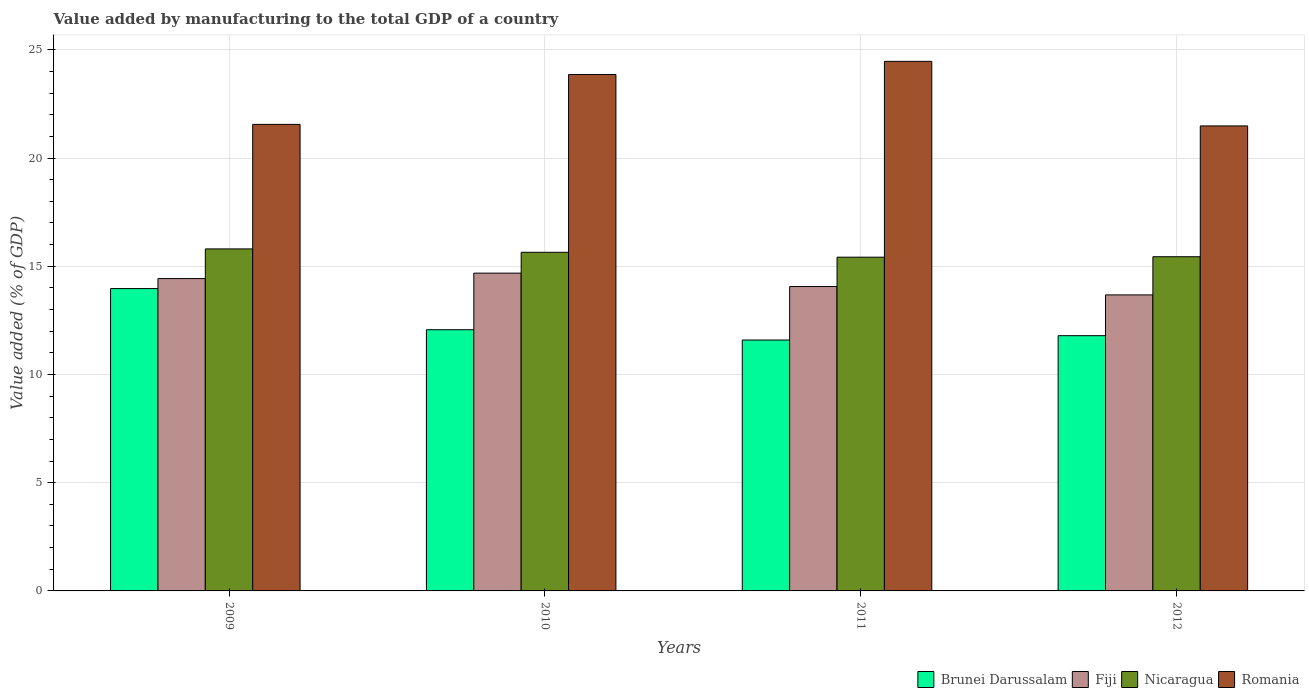How many groups of bars are there?
Provide a short and direct response. 4. Are the number of bars on each tick of the X-axis equal?
Offer a very short reply. Yes. How many bars are there on the 2nd tick from the right?
Provide a succinct answer. 4. What is the value added by manufacturing to the total GDP in Romania in 2012?
Give a very brief answer. 21.48. Across all years, what is the maximum value added by manufacturing to the total GDP in Brunei Darussalam?
Provide a succinct answer. 13.97. Across all years, what is the minimum value added by manufacturing to the total GDP in Brunei Darussalam?
Make the answer very short. 11.59. In which year was the value added by manufacturing to the total GDP in Romania maximum?
Your answer should be compact. 2011. What is the total value added by manufacturing to the total GDP in Nicaragua in the graph?
Offer a very short reply. 62.31. What is the difference between the value added by manufacturing to the total GDP in Fiji in 2009 and that in 2010?
Keep it short and to the point. -0.25. What is the difference between the value added by manufacturing to the total GDP in Fiji in 2011 and the value added by manufacturing to the total GDP in Brunei Darussalam in 2010?
Make the answer very short. 2. What is the average value added by manufacturing to the total GDP in Nicaragua per year?
Give a very brief answer. 15.58. In the year 2009, what is the difference between the value added by manufacturing to the total GDP in Nicaragua and value added by manufacturing to the total GDP in Fiji?
Provide a short and direct response. 1.37. What is the ratio of the value added by manufacturing to the total GDP in Nicaragua in 2009 to that in 2012?
Your response must be concise. 1.02. Is the value added by manufacturing to the total GDP in Romania in 2009 less than that in 2011?
Offer a very short reply. Yes. Is the difference between the value added by manufacturing to the total GDP in Nicaragua in 2009 and 2010 greater than the difference between the value added by manufacturing to the total GDP in Fiji in 2009 and 2010?
Provide a succinct answer. Yes. What is the difference between the highest and the second highest value added by manufacturing to the total GDP in Brunei Darussalam?
Provide a succinct answer. 1.9. What is the difference between the highest and the lowest value added by manufacturing to the total GDP in Brunei Darussalam?
Offer a very short reply. 2.38. Is the sum of the value added by manufacturing to the total GDP in Nicaragua in 2009 and 2010 greater than the maximum value added by manufacturing to the total GDP in Romania across all years?
Keep it short and to the point. Yes. Is it the case that in every year, the sum of the value added by manufacturing to the total GDP in Brunei Darussalam and value added by manufacturing to the total GDP in Fiji is greater than the sum of value added by manufacturing to the total GDP in Nicaragua and value added by manufacturing to the total GDP in Romania?
Offer a very short reply. No. What does the 3rd bar from the left in 2010 represents?
Give a very brief answer. Nicaragua. What does the 4th bar from the right in 2012 represents?
Your answer should be compact. Brunei Darussalam. How many bars are there?
Provide a short and direct response. 16. Are all the bars in the graph horizontal?
Keep it short and to the point. No. How many years are there in the graph?
Make the answer very short. 4. What is the difference between two consecutive major ticks on the Y-axis?
Provide a succinct answer. 5. How many legend labels are there?
Your response must be concise. 4. What is the title of the graph?
Provide a succinct answer. Value added by manufacturing to the total GDP of a country. What is the label or title of the X-axis?
Give a very brief answer. Years. What is the label or title of the Y-axis?
Provide a succinct answer. Value added (% of GDP). What is the Value added (% of GDP) of Brunei Darussalam in 2009?
Make the answer very short. 13.97. What is the Value added (% of GDP) in Fiji in 2009?
Your answer should be very brief. 14.43. What is the Value added (% of GDP) of Nicaragua in 2009?
Offer a terse response. 15.8. What is the Value added (% of GDP) of Romania in 2009?
Offer a terse response. 21.56. What is the Value added (% of GDP) of Brunei Darussalam in 2010?
Make the answer very short. 12.07. What is the Value added (% of GDP) in Fiji in 2010?
Ensure brevity in your answer.  14.68. What is the Value added (% of GDP) in Nicaragua in 2010?
Keep it short and to the point. 15.65. What is the Value added (% of GDP) in Romania in 2010?
Provide a short and direct response. 23.86. What is the Value added (% of GDP) of Brunei Darussalam in 2011?
Give a very brief answer. 11.59. What is the Value added (% of GDP) in Fiji in 2011?
Keep it short and to the point. 14.06. What is the Value added (% of GDP) of Nicaragua in 2011?
Offer a terse response. 15.42. What is the Value added (% of GDP) of Romania in 2011?
Keep it short and to the point. 24.47. What is the Value added (% of GDP) of Brunei Darussalam in 2012?
Ensure brevity in your answer.  11.79. What is the Value added (% of GDP) in Fiji in 2012?
Make the answer very short. 13.68. What is the Value added (% of GDP) of Nicaragua in 2012?
Keep it short and to the point. 15.44. What is the Value added (% of GDP) in Romania in 2012?
Offer a very short reply. 21.48. Across all years, what is the maximum Value added (% of GDP) of Brunei Darussalam?
Offer a terse response. 13.97. Across all years, what is the maximum Value added (% of GDP) of Fiji?
Offer a very short reply. 14.68. Across all years, what is the maximum Value added (% of GDP) in Nicaragua?
Keep it short and to the point. 15.8. Across all years, what is the maximum Value added (% of GDP) in Romania?
Provide a succinct answer. 24.47. Across all years, what is the minimum Value added (% of GDP) of Brunei Darussalam?
Give a very brief answer. 11.59. Across all years, what is the minimum Value added (% of GDP) of Fiji?
Your answer should be very brief. 13.68. Across all years, what is the minimum Value added (% of GDP) of Nicaragua?
Your response must be concise. 15.42. Across all years, what is the minimum Value added (% of GDP) in Romania?
Your response must be concise. 21.48. What is the total Value added (% of GDP) of Brunei Darussalam in the graph?
Your response must be concise. 49.42. What is the total Value added (% of GDP) in Fiji in the graph?
Offer a very short reply. 56.85. What is the total Value added (% of GDP) of Nicaragua in the graph?
Offer a very short reply. 62.31. What is the total Value added (% of GDP) in Romania in the graph?
Provide a short and direct response. 91.37. What is the difference between the Value added (% of GDP) of Brunei Darussalam in 2009 and that in 2010?
Give a very brief answer. 1.9. What is the difference between the Value added (% of GDP) in Fiji in 2009 and that in 2010?
Your response must be concise. -0.25. What is the difference between the Value added (% of GDP) of Nicaragua in 2009 and that in 2010?
Offer a terse response. 0.16. What is the difference between the Value added (% of GDP) in Romania in 2009 and that in 2010?
Provide a succinct answer. -2.3. What is the difference between the Value added (% of GDP) of Brunei Darussalam in 2009 and that in 2011?
Provide a succinct answer. 2.38. What is the difference between the Value added (% of GDP) in Fiji in 2009 and that in 2011?
Make the answer very short. 0.37. What is the difference between the Value added (% of GDP) in Nicaragua in 2009 and that in 2011?
Ensure brevity in your answer.  0.38. What is the difference between the Value added (% of GDP) of Romania in 2009 and that in 2011?
Provide a short and direct response. -2.91. What is the difference between the Value added (% of GDP) in Brunei Darussalam in 2009 and that in 2012?
Provide a succinct answer. 2.18. What is the difference between the Value added (% of GDP) of Fiji in 2009 and that in 2012?
Give a very brief answer. 0.75. What is the difference between the Value added (% of GDP) of Nicaragua in 2009 and that in 2012?
Offer a terse response. 0.36. What is the difference between the Value added (% of GDP) of Romania in 2009 and that in 2012?
Make the answer very short. 0.07. What is the difference between the Value added (% of GDP) in Brunei Darussalam in 2010 and that in 2011?
Provide a short and direct response. 0.48. What is the difference between the Value added (% of GDP) in Fiji in 2010 and that in 2011?
Provide a succinct answer. 0.62. What is the difference between the Value added (% of GDP) of Nicaragua in 2010 and that in 2011?
Offer a very short reply. 0.23. What is the difference between the Value added (% of GDP) in Romania in 2010 and that in 2011?
Give a very brief answer. -0.61. What is the difference between the Value added (% of GDP) in Brunei Darussalam in 2010 and that in 2012?
Your answer should be very brief. 0.27. What is the difference between the Value added (% of GDP) in Fiji in 2010 and that in 2012?
Your response must be concise. 1.01. What is the difference between the Value added (% of GDP) of Nicaragua in 2010 and that in 2012?
Your answer should be compact. 0.21. What is the difference between the Value added (% of GDP) of Romania in 2010 and that in 2012?
Make the answer very short. 2.38. What is the difference between the Value added (% of GDP) of Brunei Darussalam in 2011 and that in 2012?
Your answer should be compact. -0.2. What is the difference between the Value added (% of GDP) in Fiji in 2011 and that in 2012?
Your answer should be very brief. 0.39. What is the difference between the Value added (% of GDP) in Nicaragua in 2011 and that in 2012?
Offer a terse response. -0.02. What is the difference between the Value added (% of GDP) of Romania in 2011 and that in 2012?
Your answer should be very brief. 2.98. What is the difference between the Value added (% of GDP) in Brunei Darussalam in 2009 and the Value added (% of GDP) in Fiji in 2010?
Provide a short and direct response. -0.71. What is the difference between the Value added (% of GDP) of Brunei Darussalam in 2009 and the Value added (% of GDP) of Nicaragua in 2010?
Make the answer very short. -1.68. What is the difference between the Value added (% of GDP) of Brunei Darussalam in 2009 and the Value added (% of GDP) of Romania in 2010?
Your answer should be very brief. -9.89. What is the difference between the Value added (% of GDP) in Fiji in 2009 and the Value added (% of GDP) in Nicaragua in 2010?
Make the answer very short. -1.21. What is the difference between the Value added (% of GDP) in Fiji in 2009 and the Value added (% of GDP) in Romania in 2010?
Give a very brief answer. -9.43. What is the difference between the Value added (% of GDP) in Nicaragua in 2009 and the Value added (% of GDP) in Romania in 2010?
Ensure brevity in your answer.  -8.06. What is the difference between the Value added (% of GDP) in Brunei Darussalam in 2009 and the Value added (% of GDP) in Fiji in 2011?
Your response must be concise. -0.09. What is the difference between the Value added (% of GDP) in Brunei Darussalam in 2009 and the Value added (% of GDP) in Nicaragua in 2011?
Ensure brevity in your answer.  -1.45. What is the difference between the Value added (% of GDP) in Brunei Darussalam in 2009 and the Value added (% of GDP) in Romania in 2011?
Ensure brevity in your answer.  -10.5. What is the difference between the Value added (% of GDP) of Fiji in 2009 and the Value added (% of GDP) of Nicaragua in 2011?
Offer a terse response. -0.99. What is the difference between the Value added (% of GDP) of Fiji in 2009 and the Value added (% of GDP) of Romania in 2011?
Offer a very short reply. -10.04. What is the difference between the Value added (% of GDP) in Nicaragua in 2009 and the Value added (% of GDP) in Romania in 2011?
Make the answer very short. -8.67. What is the difference between the Value added (% of GDP) in Brunei Darussalam in 2009 and the Value added (% of GDP) in Fiji in 2012?
Your answer should be compact. 0.29. What is the difference between the Value added (% of GDP) in Brunei Darussalam in 2009 and the Value added (% of GDP) in Nicaragua in 2012?
Offer a very short reply. -1.47. What is the difference between the Value added (% of GDP) in Brunei Darussalam in 2009 and the Value added (% of GDP) in Romania in 2012?
Offer a terse response. -7.51. What is the difference between the Value added (% of GDP) in Fiji in 2009 and the Value added (% of GDP) in Nicaragua in 2012?
Provide a short and direct response. -1.01. What is the difference between the Value added (% of GDP) of Fiji in 2009 and the Value added (% of GDP) of Romania in 2012?
Give a very brief answer. -7.05. What is the difference between the Value added (% of GDP) in Nicaragua in 2009 and the Value added (% of GDP) in Romania in 2012?
Make the answer very short. -5.68. What is the difference between the Value added (% of GDP) in Brunei Darussalam in 2010 and the Value added (% of GDP) in Fiji in 2011?
Provide a short and direct response. -2. What is the difference between the Value added (% of GDP) in Brunei Darussalam in 2010 and the Value added (% of GDP) in Nicaragua in 2011?
Provide a short and direct response. -3.35. What is the difference between the Value added (% of GDP) of Brunei Darussalam in 2010 and the Value added (% of GDP) of Romania in 2011?
Provide a short and direct response. -12.4. What is the difference between the Value added (% of GDP) in Fiji in 2010 and the Value added (% of GDP) in Nicaragua in 2011?
Give a very brief answer. -0.74. What is the difference between the Value added (% of GDP) of Fiji in 2010 and the Value added (% of GDP) of Romania in 2011?
Your answer should be very brief. -9.78. What is the difference between the Value added (% of GDP) in Nicaragua in 2010 and the Value added (% of GDP) in Romania in 2011?
Make the answer very short. -8.82. What is the difference between the Value added (% of GDP) of Brunei Darussalam in 2010 and the Value added (% of GDP) of Fiji in 2012?
Keep it short and to the point. -1.61. What is the difference between the Value added (% of GDP) in Brunei Darussalam in 2010 and the Value added (% of GDP) in Nicaragua in 2012?
Give a very brief answer. -3.37. What is the difference between the Value added (% of GDP) of Brunei Darussalam in 2010 and the Value added (% of GDP) of Romania in 2012?
Keep it short and to the point. -9.42. What is the difference between the Value added (% of GDP) in Fiji in 2010 and the Value added (% of GDP) in Nicaragua in 2012?
Ensure brevity in your answer.  -0.76. What is the difference between the Value added (% of GDP) of Fiji in 2010 and the Value added (% of GDP) of Romania in 2012?
Give a very brief answer. -6.8. What is the difference between the Value added (% of GDP) in Nicaragua in 2010 and the Value added (% of GDP) in Romania in 2012?
Your answer should be very brief. -5.84. What is the difference between the Value added (% of GDP) of Brunei Darussalam in 2011 and the Value added (% of GDP) of Fiji in 2012?
Offer a very short reply. -2.08. What is the difference between the Value added (% of GDP) in Brunei Darussalam in 2011 and the Value added (% of GDP) in Nicaragua in 2012?
Offer a very short reply. -3.85. What is the difference between the Value added (% of GDP) of Brunei Darussalam in 2011 and the Value added (% of GDP) of Romania in 2012?
Keep it short and to the point. -9.89. What is the difference between the Value added (% of GDP) of Fiji in 2011 and the Value added (% of GDP) of Nicaragua in 2012?
Your answer should be very brief. -1.38. What is the difference between the Value added (% of GDP) of Fiji in 2011 and the Value added (% of GDP) of Romania in 2012?
Your response must be concise. -7.42. What is the difference between the Value added (% of GDP) in Nicaragua in 2011 and the Value added (% of GDP) in Romania in 2012?
Your answer should be very brief. -6.06. What is the average Value added (% of GDP) of Brunei Darussalam per year?
Provide a succinct answer. 12.36. What is the average Value added (% of GDP) in Fiji per year?
Keep it short and to the point. 14.21. What is the average Value added (% of GDP) of Nicaragua per year?
Your answer should be very brief. 15.58. What is the average Value added (% of GDP) of Romania per year?
Make the answer very short. 22.84. In the year 2009, what is the difference between the Value added (% of GDP) in Brunei Darussalam and Value added (% of GDP) in Fiji?
Offer a terse response. -0.46. In the year 2009, what is the difference between the Value added (% of GDP) of Brunei Darussalam and Value added (% of GDP) of Nicaragua?
Make the answer very short. -1.83. In the year 2009, what is the difference between the Value added (% of GDP) of Brunei Darussalam and Value added (% of GDP) of Romania?
Ensure brevity in your answer.  -7.59. In the year 2009, what is the difference between the Value added (% of GDP) of Fiji and Value added (% of GDP) of Nicaragua?
Your response must be concise. -1.37. In the year 2009, what is the difference between the Value added (% of GDP) of Fiji and Value added (% of GDP) of Romania?
Give a very brief answer. -7.12. In the year 2009, what is the difference between the Value added (% of GDP) of Nicaragua and Value added (% of GDP) of Romania?
Give a very brief answer. -5.75. In the year 2010, what is the difference between the Value added (% of GDP) in Brunei Darussalam and Value added (% of GDP) in Fiji?
Keep it short and to the point. -2.61. In the year 2010, what is the difference between the Value added (% of GDP) of Brunei Darussalam and Value added (% of GDP) of Nicaragua?
Your answer should be very brief. -3.58. In the year 2010, what is the difference between the Value added (% of GDP) in Brunei Darussalam and Value added (% of GDP) in Romania?
Offer a very short reply. -11.79. In the year 2010, what is the difference between the Value added (% of GDP) in Fiji and Value added (% of GDP) in Nicaragua?
Provide a short and direct response. -0.96. In the year 2010, what is the difference between the Value added (% of GDP) of Fiji and Value added (% of GDP) of Romania?
Make the answer very short. -9.18. In the year 2010, what is the difference between the Value added (% of GDP) of Nicaragua and Value added (% of GDP) of Romania?
Make the answer very short. -8.21. In the year 2011, what is the difference between the Value added (% of GDP) in Brunei Darussalam and Value added (% of GDP) in Fiji?
Keep it short and to the point. -2.47. In the year 2011, what is the difference between the Value added (% of GDP) of Brunei Darussalam and Value added (% of GDP) of Nicaragua?
Offer a very short reply. -3.83. In the year 2011, what is the difference between the Value added (% of GDP) in Brunei Darussalam and Value added (% of GDP) in Romania?
Your answer should be compact. -12.88. In the year 2011, what is the difference between the Value added (% of GDP) of Fiji and Value added (% of GDP) of Nicaragua?
Ensure brevity in your answer.  -1.36. In the year 2011, what is the difference between the Value added (% of GDP) in Fiji and Value added (% of GDP) in Romania?
Your response must be concise. -10.4. In the year 2011, what is the difference between the Value added (% of GDP) of Nicaragua and Value added (% of GDP) of Romania?
Offer a terse response. -9.05. In the year 2012, what is the difference between the Value added (% of GDP) of Brunei Darussalam and Value added (% of GDP) of Fiji?
Offer a terse response. -1.88. In the year 2012, what is the difference between the Value added (% of GDP) in Brunei Darussalam and Value added (% of GDP) in Nicaragua?
Ensure brevity in your answer.  -3.65. In the year 2012, what is the difference between the Value added (% of GDP) in Brunei Darussalam and Value added (% of GDP) in Romania?
Offer a very short reply. -9.69. In the year 2012, what is the difference between the Value added (% of GDP) of Fiji and Value added (% of GDP) of Nicaragua?
Your answer should be compact. -1.76. In the year 2012, what is the difference between the Value added (% of GDP) in Fiji and Value added (% of GDP) in Romania?
Give a very brief answer. -7.81. In the year 2012, what is the difference between the Value added (% of GDP) of Nicaragua and Value added (% of GDP) of Romania?
Provide a short and direct response. -6.04. What is the ratio of the Value added (% of GDP) in Brunei Darussalam in 2009 to that in 2010?
Ensure brevity in your answer.  1.16. What is the ratio of the Value added (% of GDP) in Fiji in 2009 to that in 2010?
Your answer should be very brief. 0.98. What is the ratio of the Value added (% of GDP) in Nicaragua in 2009 to that in 2010?
Ensure brevity in your answer.  1.01. What is the ratio of the Value added (% of GDP) in Romania in 2009 to that in 2010?
Your response must be concise. 0.9. What is the ratio of the Value added (% of GDP) of Brunei Darussalam in 2009 to that in 2011?
Make the answer very short. 1.21. What is the ratio of the Value added (% of GDP) in Fiji in 2009 to that in 2011?
Your answer should be compact. 1.03. What is the ratio of the Value added (% of GDP) of Nicaragua in 2009 to that in 2011?
Your answer should be very brief. 1.02. What is the ratio of the Value added (% of GDP) of Romania in 2009 to that in 2011?
Keep it short and to the point. 0.88. What is the ratio of the Value added (% of GDP) of Brunei Darussalam in 2009 to that in 2012?
Keep it short and to the point. 1.18. What is the ratio of the Value added (% of GDP) of Fiji in 2009 to that in 2012?
Your answer should be compact. 1.06. What is the ratio of the Value added (% of GDP) in Nicaragua in 2009 to that in 2012?
Give a very brief answer. 1.02. What is the ratio of the Value added (% of GDP) of Romania in 2009 to that in 2012?
Your answer should be very brief. 1. What is the ratio of the Value added (% of GDP) of Brunei Darussalam in 2010 to that in 2011?
Provide a short and direct response. 1.04. What is the ratio of the Value added (% of GDP) of Fiji in 2010 to that in 2011?
Give a very brief answer. 1.04. What is the ratio of the Value added (% of GDP) in Nicaragua in 2010 to that in 2011?
Provide a succinct answer. 1.01. What is the ratio of the Value added (% of GDP) in Romania in 2010 to that in 2011?
Offer a terse response. 0.98. What is the ratio of the Value added (% of GDP) in Brunei Darussalam in 2010 to that in 2012?
Your answer should be very brief. 1.02. What is the ratio of the Value added (% of GDP) in Fiji in 2010 to that in 2012?
Your response must be concise. 1.07. What is the ratio of the Value added (% of GDP) of Nicaragua in 2010 to that in 2012?
Provide a succinct answer. 1.01. What is the ratio of the Value added (% of GDP) in Romania in 2010 to that in 2012?
Your answer should be compact. 1.11. What is the ratio of the Value added (% of GDP) of Brunei Darussalam in 2011 to that in 2012?
Your answer should be very brief. 0.98. What is the ratio of the Value added (% of GDP) in Fiji in 2011 to that in 2012?
Your answer should be compact. 1.03. What is the ratio of the Value added (% of GDP) in Romania in 2011 to that in 2012?
Give a very brief answer. 1.14. What is the difference between the highest and the second highest Value added (% of GDP) in Brunei Darussalam?
Make the answer very short. 1.9. What is the difference between the highest and the second highest Value added (% of GDP) in Fiji?
Your answer should be compact. 0.25. What is the difference between the highest and the second highest Value added (% of GDP) of Nicaragua?
Keep it short and to the point. 0.16. What is the difference between the highest and the second highest Value added (% of GDP) in Romania?
Your response must be concise. 0.61. What is the difference between the highest and the lowest Value added (% of GDP) of Brunei Darussalam?
Provide a succinct answer. 2.38. What is the difference between the highest and the lowest Value added (% of GDP) of Fiji?
Provide a short and direct response. 1.01. What is the difference between the highest and the lowest Value added (% of GDP) in Nicaragua?
Keep it short and to the point. 0.38. What is the difference between the highest and the lowest Value added (% of GDP) in Romania?
Offer a terse response. 2.98. 